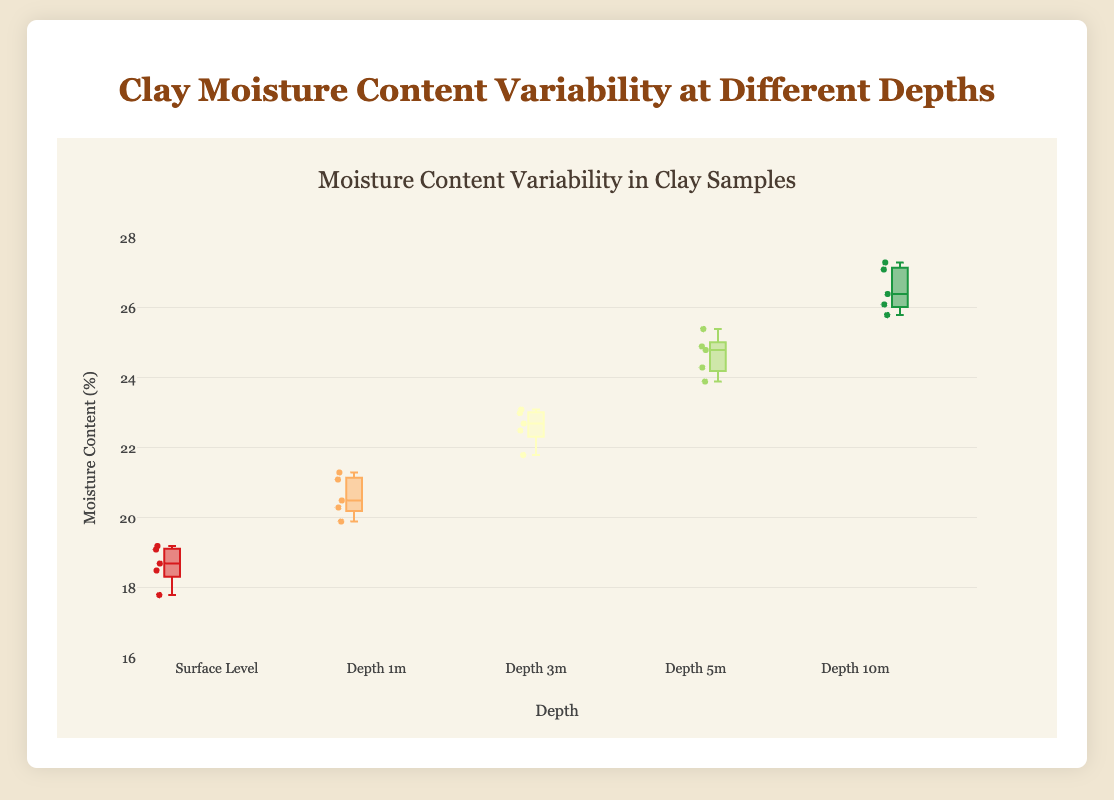What is the title of the figure? The title is usually prominently displayed at the top of the figure. In this case, it reads "Clay Moisture Content Variability at Different Depths."
Answer: Clay Moisture Content Variability at Different Depths What is the range of y-axis values? The range of y-axis values can be seen on the left side of the plot. It starts at 16 and goes up to 28.
Answer: 16 to 28 Which depth has the highest median moisture content? The median is the line inside each box. The box representing "Depth 10m" has the highest median, which can be seen by comparing the line positions across all boxes.
Answer: Depth 10m Which depth has the most variability in moisture content? To find variability, we compare the interquartile range (IQR), which is the height of each box. The taller box has more variability. "Depth 10m" has the tallest box, indicating the most variability.
Answer: Depth 10m What is the approximate median moisture content at Depth 5m? The median is the line within the box. For "Depth 5m," this line is around 24.3.
Answer: Around 24.3 How does the median moisture content change with depth? The median increases with depth. The surface starts around 18.5 and rises gradually at each depth level, reaching about 26.5 at 10m.
Answer: It increases What is the color used for the box representing Depth 3m? The color of the box for "Depth 3m" can be observed visually. It's a light yellow shade.
Answer: Light yellow Which depth has the least data points? Each depth shows five data points, indicated by the individual points on the boxes. All depths have an equal number of points.
Answer: All depths have the same number of data points Which depths exhibit overlapping interquartile ranges? Overlapping IQR ranges occur when the boxes overlap vertically. The depths "Depth 1m" and "Depth 3m" have overlapping boxes.
Answer: Depth 1m and Depth 3m What is the increase in median moisture content from Surface Level to Depth 10m? The median for the Surface Level is around 18.5, and for Depth 10m is about 26.5. The increase is 26.5 - 18.5 = 8.
Answer: 8 